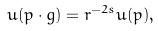<formula> <loc_0><loc_0><loc_500><loc_500>u ( p \cdot g ) = r ^ { - 2 s } u ( p ) ,</formula> 